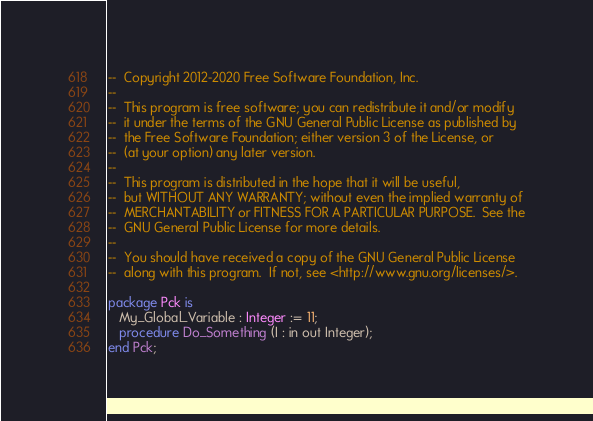Convert code to text. <code><loc_0><loc_0><loc_500><loc_500><_Ada_>--  Copyright 2012-2020 Free Software Foundation, Inc.
--
--  This program is free software; you can redistribute it and/or modify
--  it under the terms of the GNU General Public License as published by
--  the Free Software Foundation; either version 3 of the License, or
--  (at your option) any later version.
--
--  This program is distributed in the hope that it will be useful,
--  but WITHOUT ANY WARRANTY; without even the implied warranty of
--  MERCHANTABILITY or FITNESS FOR A PARTICULAR PURPOSE.  See the
--  GNU General Public License for more details.
--
--  You should have received a copy of the GNU General Public License
--  along with this program.  If not, see <http://www.gnu.org/licenses/>.

package Pck is
   My_Global_Variable : Integer := 11;
   procedure Do_Something (I : in out Integer);
end Pck;

</code> 